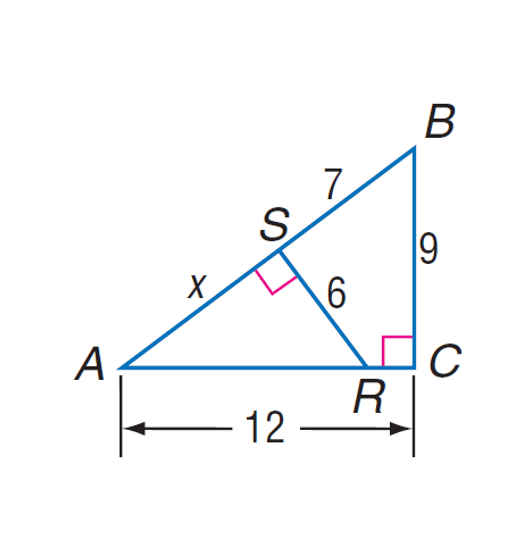Answer the mathemtical geometry problem and directly provide the correct option letter.
Question: Find A S.
Choices: A: 7 B: 7.8 C: 8 D: 9.2 C 